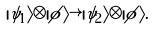Convert formula to latex. <formula><loc_0><loc_0><loc_500><loc_500>| \psi _ { 1 } \rangle \otimes | \phi \rangle \rightarrow | \psi _ { 2 } \rangle \otimes | \phi \rangle .</formula> 